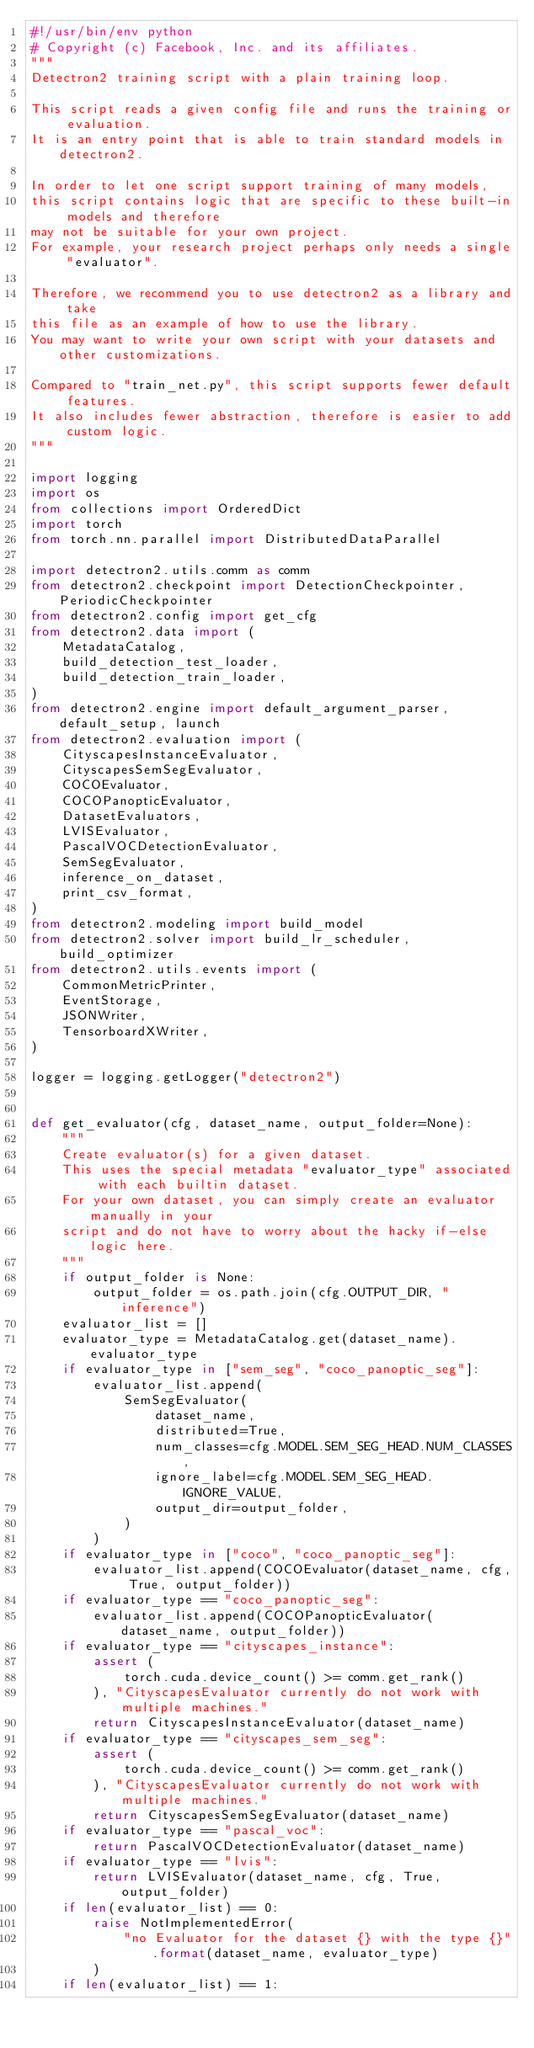Convert code to text. <code><loc_0><loc_0><loc_500><loc_500><_Python_>#!/usr/bin/env python
# Copyright (c) Facebook, Inc. and its affiliates.
"""
Detectron2 training script with a plain training loop.

This script reads a given config file and runs the training or evaluation.
It is an entry point that is able to train standard models in detectron2.

In order to let one script support training of many models,
this script contains logic that are specific to these built-in models and therefore
may not be suitable for your own project.
For example, your research project perhaps only needs a single "evaluator".

Therefore, we recommend you to use detectron2 as a library and take
this file as an example of how to use the library.
You may want to write your own script with your datasets and other customizations.

Compared to "train_net.py", this script supports fewer default features.
It also includes fewer abstraction, therefore is easier to add custom logic.
"""

import logging
import os
from collections import OrderedDict
import torch
from torch.nn.parallel import DistributedDataParallel

import detectron2.utils.comm as comm
from detectron2.checkpoint import DetectionCheckpointer, PeriodicCheckpointer
from detectron2.config import get_cfg
from detectron2.data import (
    MetadataCatalog,
    build_detection_test_loader,
    build_detection_train_loader,
)
from detectron2.engine import default_argument_parser, default_setup, launch
from detectron2.evaluation import (
    CityscapesInstanceEvaluator,
    CityscapesSemSegEvaluator,
    COCOEvaluator,
    COCOPanopticEvaluator,
    DatasetEvaluators,
    LVISEvaluator,
    PascalVOCDetectionEvaluator,
    SemSegEvaluator,
    inference_on_dataset,
    print_csv_format,
)
from detectron2.modeling import build_model
from detectron2.solver import build_lr_scheduler, build_optimizer
from detectron2.utils.events import (
    CommonMetricPrinter,
    EventStorage,
    JSONWriter,
    TensorboardXWriter,
)

logger = logging.getLogger("detectron2")


def get_evaluator(cfg, dataset_name, output_folder=None):
    """
    Create evaluator(s) for a given dataset.
    This uses the special metadata "evaluator_type" associated with each builtin dataset.
    For your own dataset, you can simply create an evaluator manually in your
    script and do not have to worry about the hacky if-else logic here.
    """
    if output_folder is None:
        output_folder = os.path.join(cfg.OUTPUT_DIR, "inference")
    evaluator_list = []
    evaluator_type = MetadataCatalog.get(dataset_name).evaluator_type
    if evaluator_type in ["sem_seg", "coco_panoptic_seg"]:
        evaluator_list.append(
            SemSegEvaluator(
                dataset_name,
                distributed=True,
                num_classes=cfg.MODEL.SEM_SEG_HEAD.NUM_CLASSES,
                ignore_label=cfg.MODEL.SEM_SEG_HEAD.IGNORE_VALUE,
                output_dir=output_folder,
            )
        )
    if evaluator_type in ["coco", "coco_panoptic_seg"]:
        evaluator_list.append(COCOEvaluator(dataset_name, cfg, True, output_folder))
    if evaluator_type == "coco_panoptic_seg":
        evaluator_list.append(COCOPanopticEvaluator(dataset_name, output_folder))
    if evaluator_type == "cityscapes_instance":
        assert (
            torch.cuda.device_count() >= comm.get_rank()
        ), "CityscapesEvaluator currently do not work with multiple machines."
        return CityscapesInstanceEvaluator(dataset_name)
    if evaluator_type == "cityscapes_sem_seg":
        assert (
            torch.cuda.device_count() >= comm.get_rank()
        ), "CityscapesEvaluator currently do not work with multiple machines."
        return CityscapesSemSegEvaluator(dataset_name)
    if evaluator_type == "pascal_voc":
        return PascalVOCDetectionEvaluator(dataset_name)
    if evaluator_type == "lvis":
        return LVISEvaluator(dataset_name, cfg, True, output_folder)
    if len(evaluator_list) == 0:
        raise NotImplementedError(
            "no Evaluator for the dataset {} with the type {}".format(dataset_name, evaluator_type)
        )
    if len(evaluator_list) == 1:</code> 